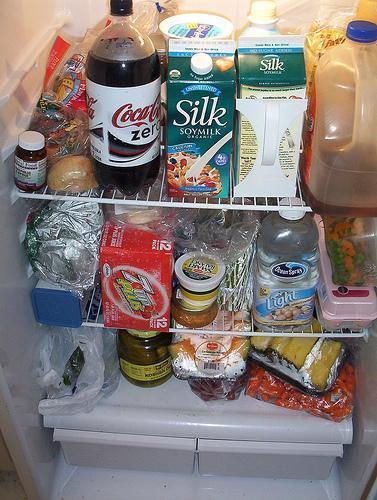How many brands of soda are pictured?
Give a very brief answer. 2. How many cartons of eggs can be seen?
Give a very brief answer. 1. 